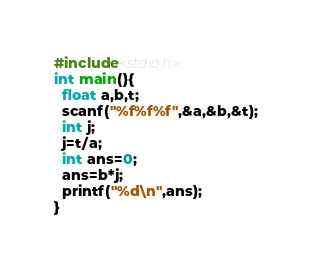<code> <loc_0><loc_0><loc_500><loc_500><_C_>#include<stdio.h>
int main(){
  float a,b,t;
  scanf("%f%f%f",&a,&b,&t);
  int j;
  j=t/a;
  int ans=0;
  ans=b*j;
  printf("%d\n",ans);
}</code> 